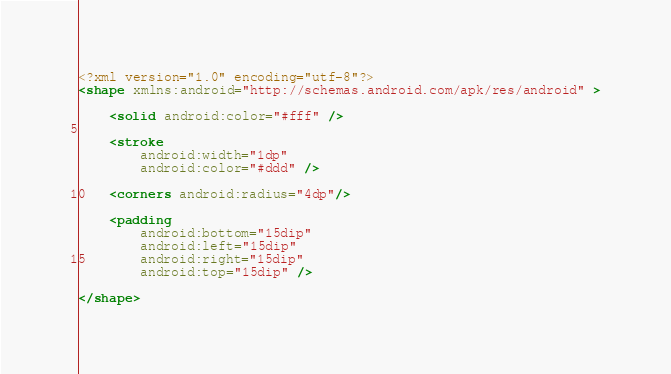Convert code to text. <code><loc_0><loc_0><loc_500><loc_500><_XML_><?xml version="1.0" encoding="utf-8"?>
<shape xmlns:android="http://schemas.android.com/apk/res/android" >

    <solid android:color="#fff" />

    <stroke
        android:width="1dp"
        android:color="#ddd" />

    <corners android:radius="4dp"/>

    <padding
        android:bottom="15dip"
        android:left="15dip"
        android:right="15dip"
        android:top="15dip" />

</shape></code> 